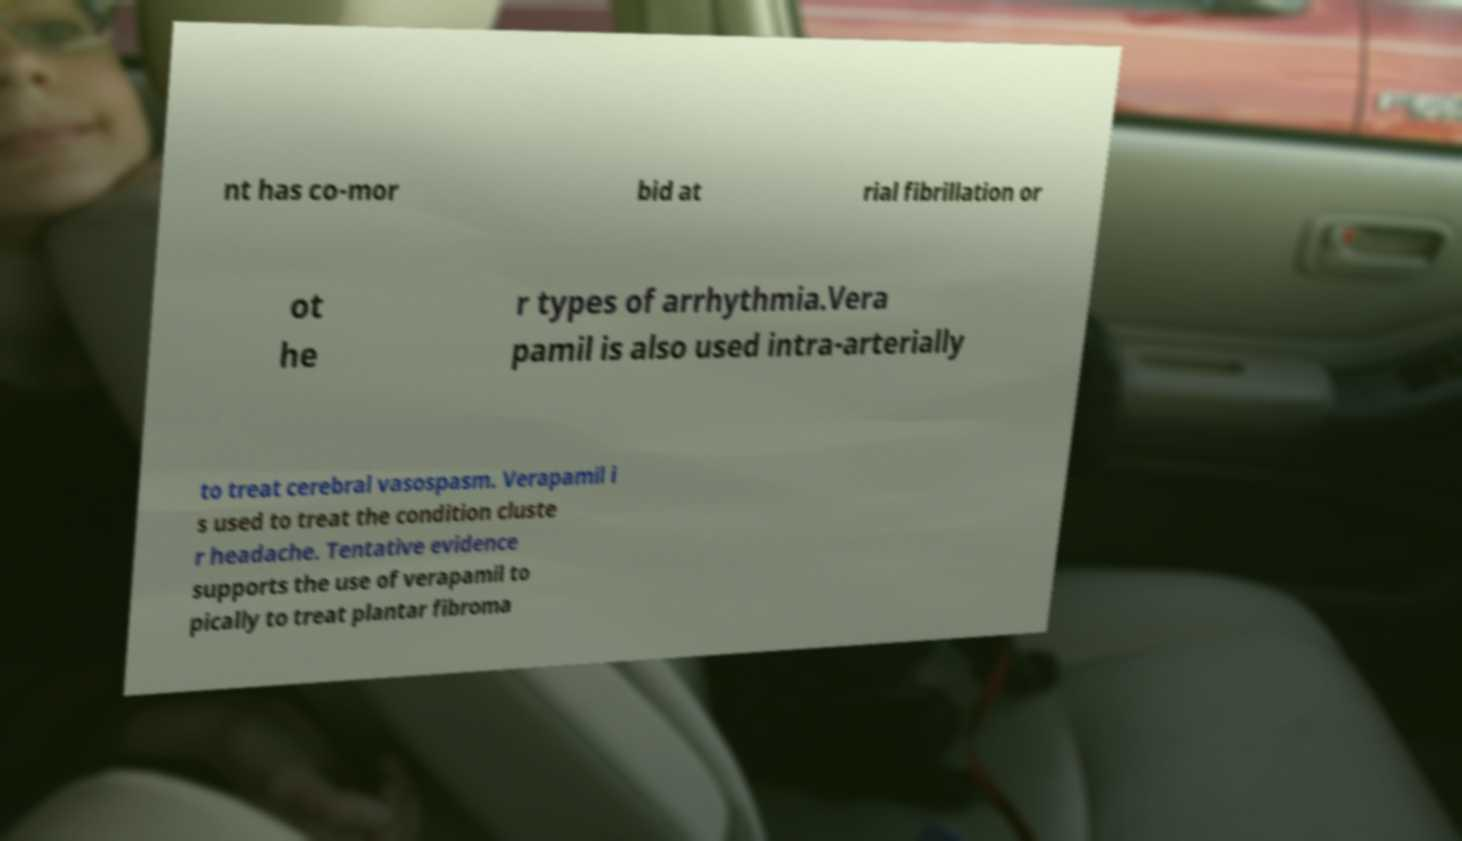For documentation purposes, I need the text within this image transcribed. Could you provide that? nt has co-mor bid at rial fibrillation or ot he r types of arrhythmia.Vera pamil is also used intra-arterially to treat cerebral vasospasm. Verapamil i s used to treat the condition cluste r headache. Tentative evidence supports the use of verapamil to pically to treat plantar fibroma 